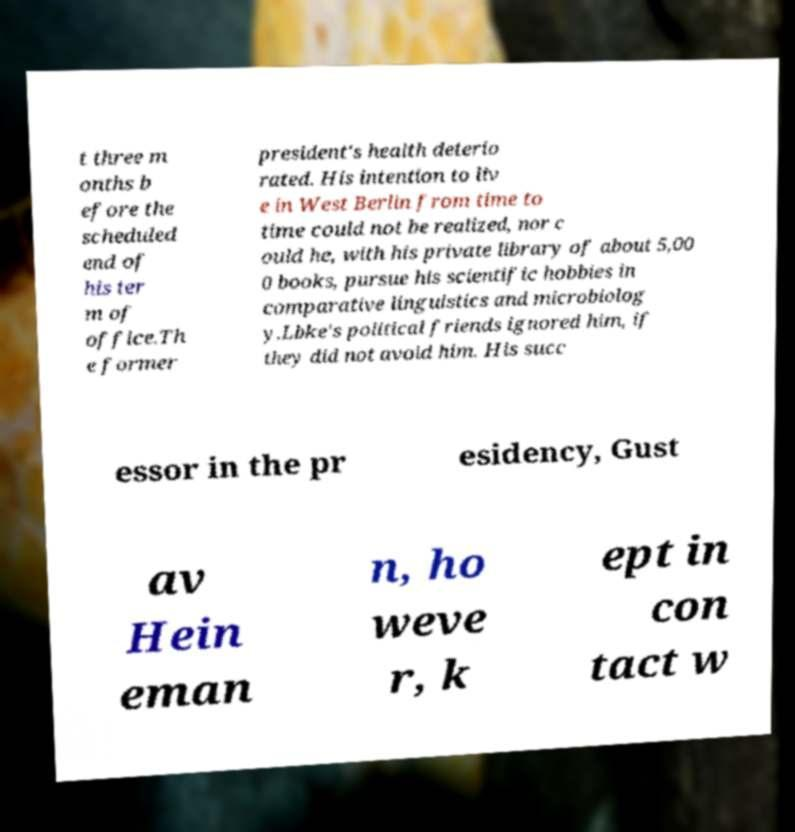I need the written content from this picture converted into text. Can you do that? t three m onths b efore the scheduled end of his ter m of office.Th e former president's health deterio rated. His intention to liv e in West Berlin from time to time could not be realized, nor c ould he, with his private library of about 5,00 0 books, pursue his scientific hobbies in comparative linguistics and microbiolog y.Lbke's political friends ignored him, if they did not avoid him. His succ essor in the pr esidency, Gust av Hein eman n, ho weve r, k ept in con tact w 